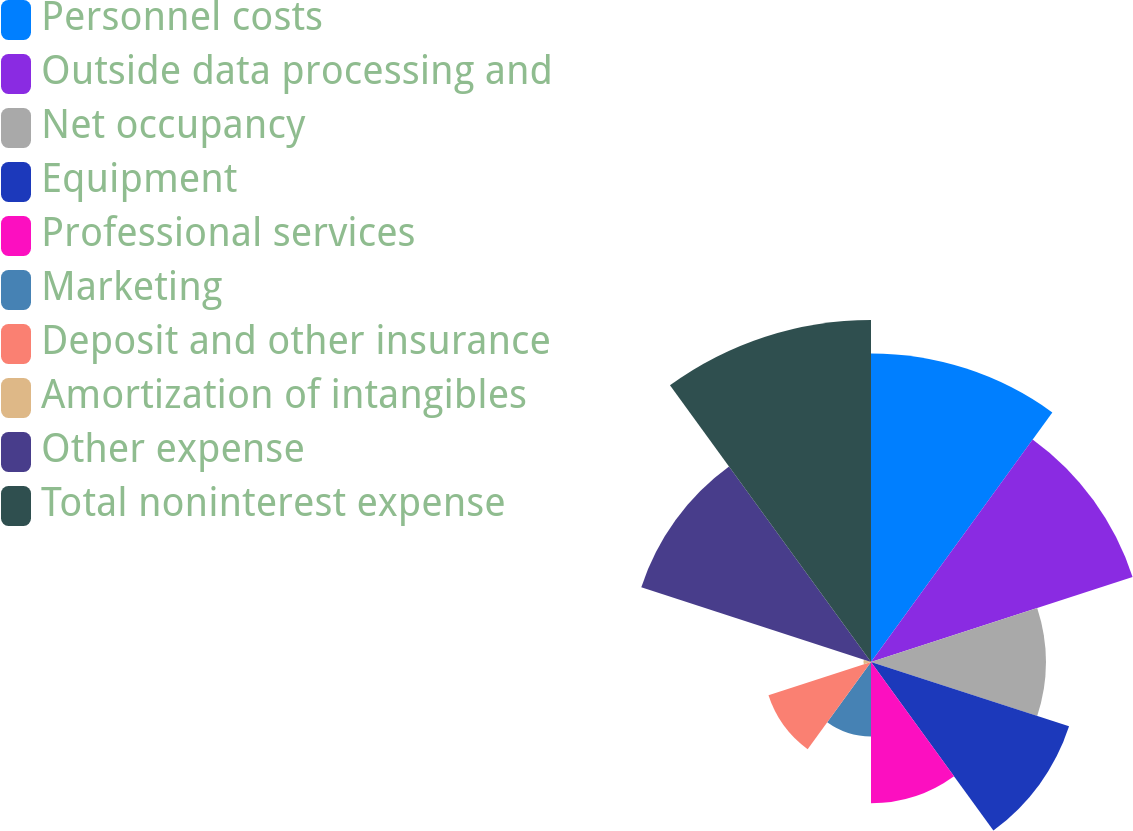Convert chart to OTSL. <chart><loc_0><loc_0><loc_500><loc_500><pie_chart><fcel>Personnel costs<fcel>Outside data processing and<fcel>Net occupancy<fcel>Equipment<fcel>Professional services<fcel>Marketing<fcel>Deposit and other insurance<fcel>Amortization of intangibles<fcel>Other expense<fcel>Total noninterest expense<nl><fcel>16.4%<fcel>14.62%<fcel>9.29%<fcel>11.07%<fcel>7.51%<fcel>3.96%<fcel>5.73%<fcel>0.4%<fcel>12.84%<fcel>18.18%<nl></chart> 